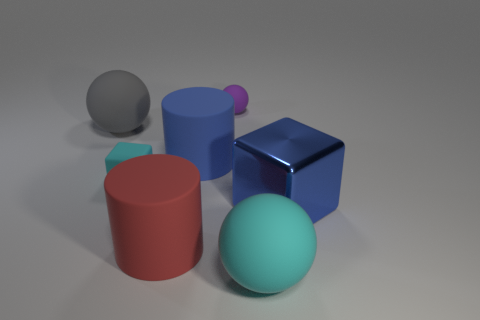Subtract 1 spheres. How many spheres are left? 2 Subtract all big rubber balls. How many balls are left? 1 Add 2 big blue rubber things. How many objects exist? 9 Subtract all cylinders. How many objects are left? 5 Subtract all brown rubber cylinders. Subtract all purple rubber things. How many objects are left? 6 Add 7 small blocks. How many small blocks are left? 8 Add 5 tiny brown rubber cylinders. How many tiny brown rubber cylinders exist? 5 Subtract 0 red cubes. How many objects are left? 7 